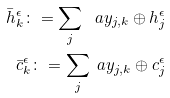<formula> <loc_0><loc_0><loc_500><loc_500>\bar { h } ^ { \epsilon } _ { k } \colon = \sum _ { j } \ a { y _ { j , k } \oplus h ^ { \epsilon } _ { j } } \\ \bar { c } ^ { \epsilon } _ { k } \colon = \sum _ { j } \ a { y _ { j , k } \oplus c ^ { \epsilon } _ { j } }</formula> 